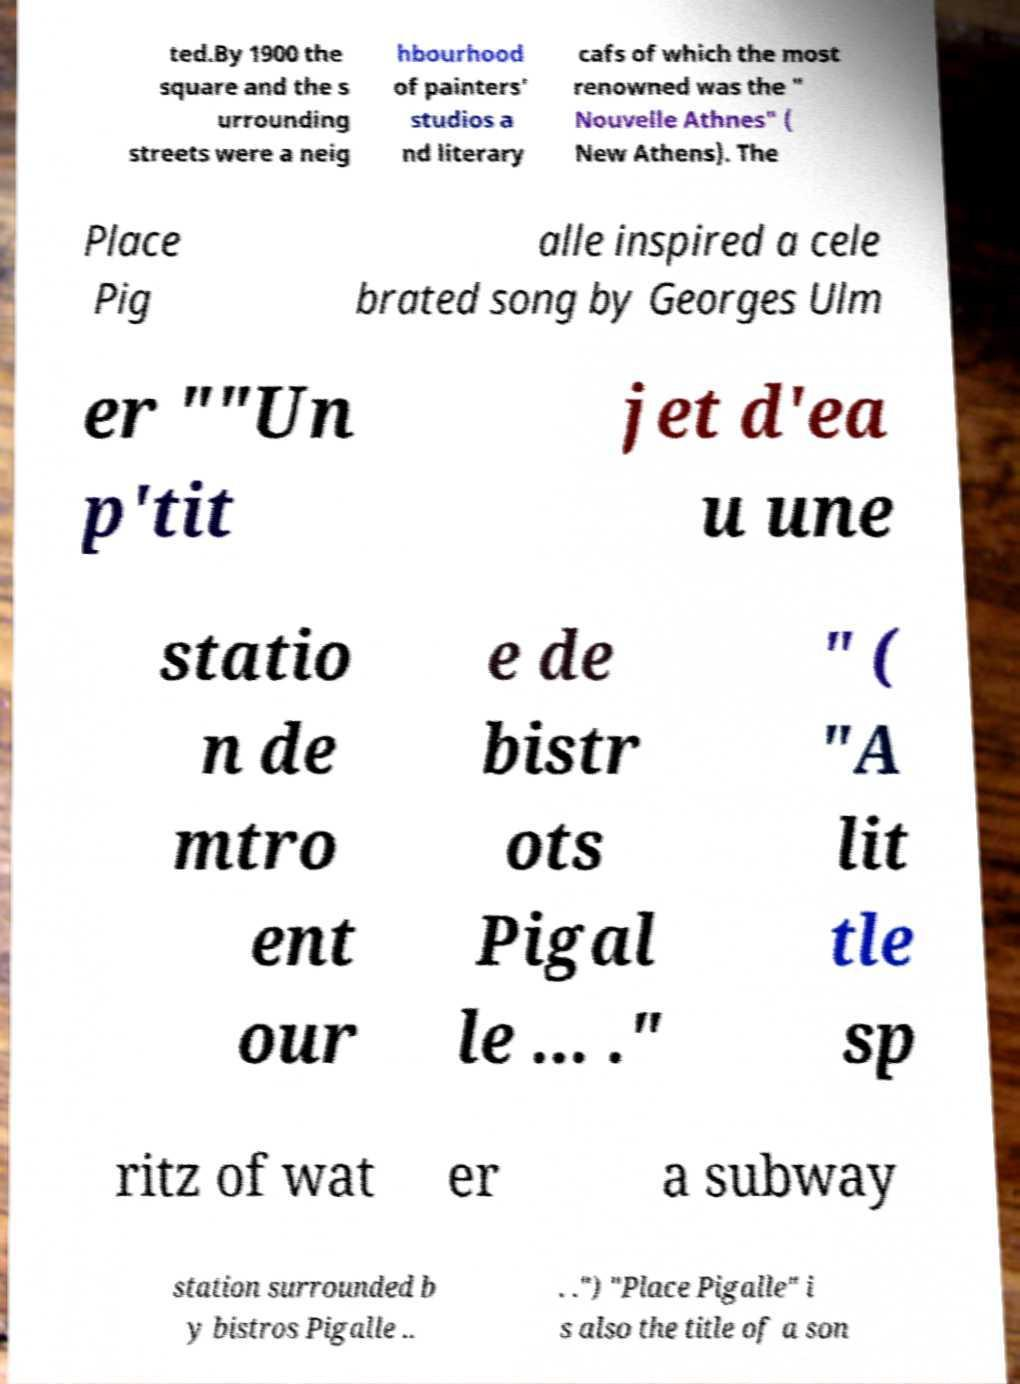Could you assist in decoding the text presented in this image and type it out clearly? ted.By 1900 the square and the s urrounding streets were a neig hbourhood of painters' studios a nd literary cafs of which the most renowned was the " Nouvelle Athnes" ( New Athens). The Place Pig alle inspired a cele brated song by Georges Ulm er ""Un p'tit jet d'ea u une statio n de mtro ent our e de bistr ots Pigal le ... ." " ( "A lit tle sp ritz of wat er a subway station surrounded b y bistros Pigalle .. . .") "Place Pigalle" i s also the title of a son 